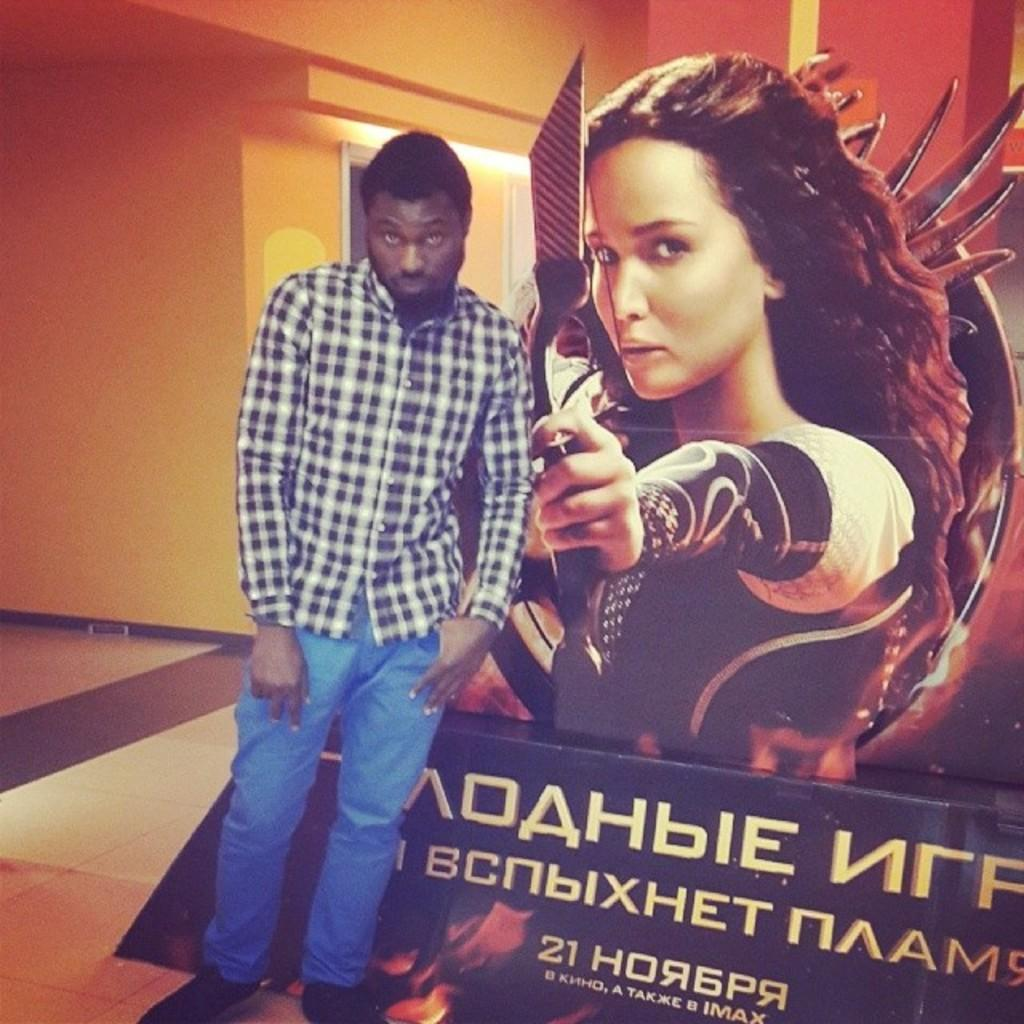What is the main subject in the image? There is a man standing in the image. What can be seen on the wall in the background? There is a poster in the image. What is the surface beneath the man's feet? There is a floor at the bottom of the image. What is the background of the image composed of? There is a wall in the background of the image. Can you see a frog hopping on the floor in the image? There is no frog present in the image. What type of cork can be seen in the man's hand in the image? There is no cork visible in the man's hand or anywhere else in the image. 